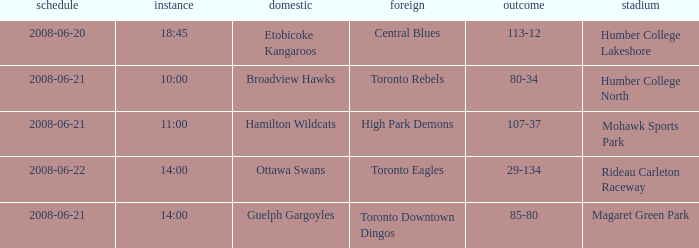What is the Date with a Home that is hamilton wildcats? 2008-06-21. 